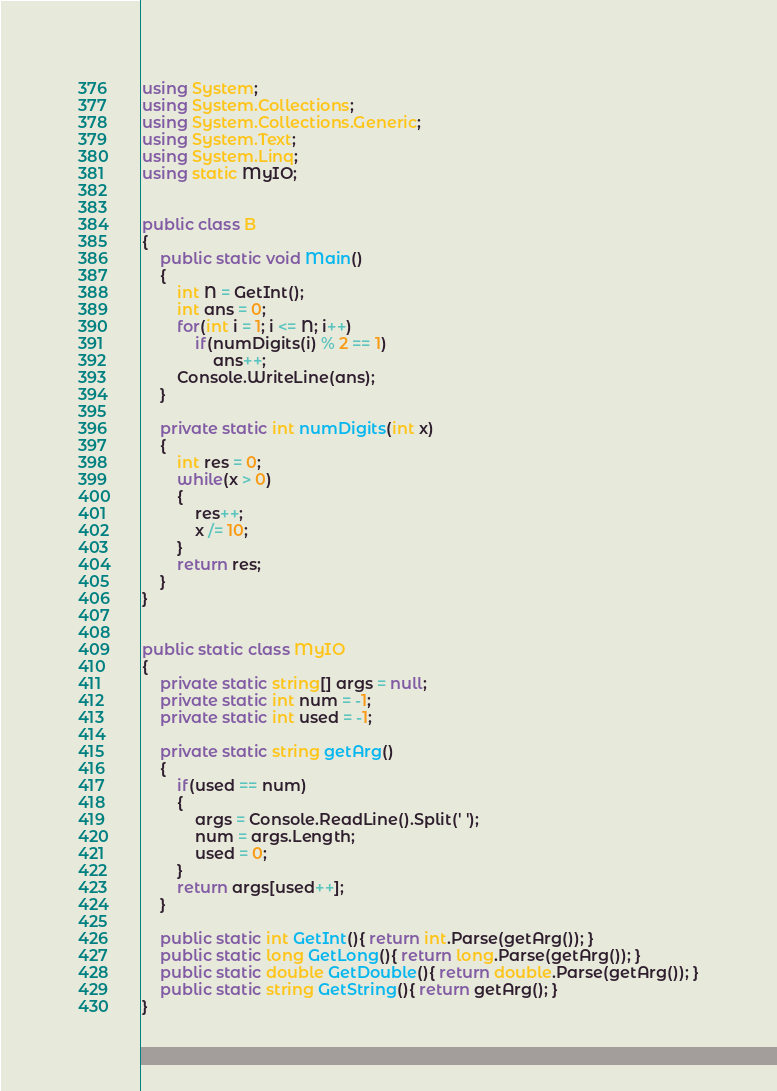<code> <loc_0><loc_0><loc_500><loc_500><_C#_>using System;
using System.Collections;
using System.Collections.Generic;
using System.Text;
using System.Linq;
using static MyIO;


public class B
{
	public static void Main()
	{
		int N = GetInt();
		int ans = 0;
		for(int i = 1; i <= N; i++)
			if(numDigits(i) % 2 == 1)
				ans++;
		Console.WriteLine(ans);
	}

	private static int numDigits(int x)
	{
		int res = 0;
		while(x > 0)
		{
			res++;
			x /= 10;
		}
		return res;
	}
}


public static class MyIO
{
	private static string[] args = null;
	private static int num = -1;
	private static int used = -1;

	private static string getArg()
	{
		if(used == num)
		{
			args = Console.ReadLine().Split(' ');
			num = args.Length;
			used = 0;
		}
		return args[used++];
	}

	public static int GetInt(){ return int.Parse(getArg()); }
	public static long GetLong(){ return long.Parse(getArg()); }
	public static double GetDouble(){ return double.Parse(getArg()); }
	public static string GetString(){ return getArg(); }
}
</code> 